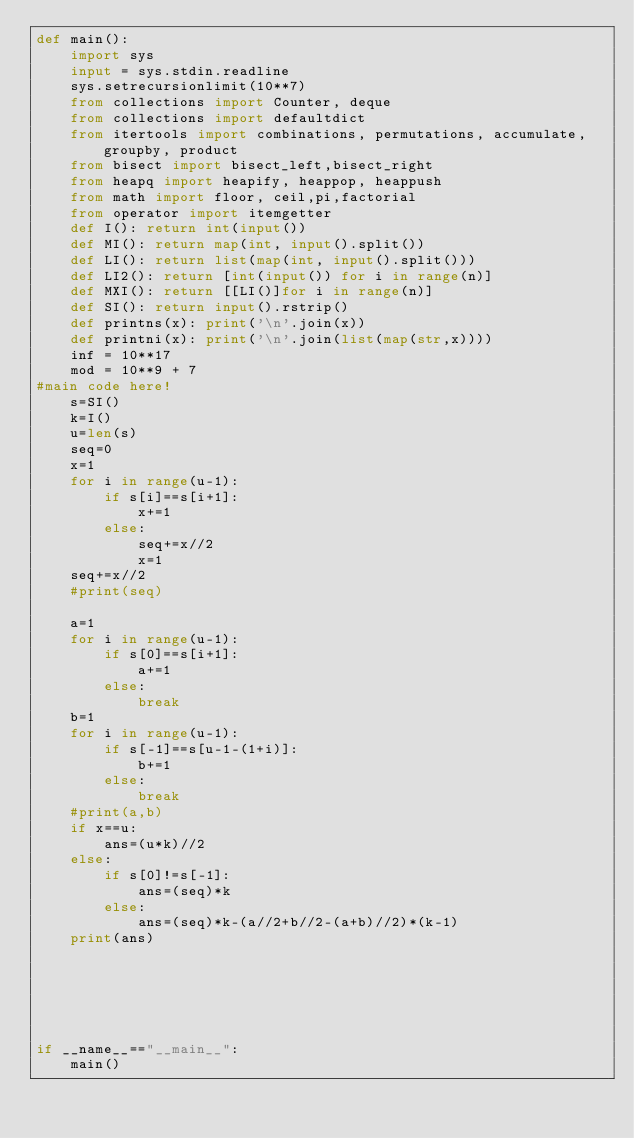Convert code to text. <code><loc_0><loc_0><loc_500><loc_500><_Python_>def main():
    import sys
    input = sys.stdin.readline
    sys.setrecursionlimit(10**7)
    from collections import Counter, deque
    from collections import defaultdict
    from itertools import combinations, permutations, accumulate, groupby, product
    from bisect import bisect_left,bisect_right
    from heapq import heapify, heappop, heappush
    from math import floor, ceil,pi,factorial
    from operator import itemgetter
    def I(): return int(input())
    def MI(): return map(int, input().split())
    def LI(): return list(map(int, input().split()))
    def LI2(): return [int(input()) for i in range(n)]
    def MXI(): return [[LI()]for i in range(n)]
    def SI(): return input().rstrip()
    def printns(x): print('\n'.join(x))
    def printni(x): print('\n'.join(list(map(str,x))))
    inf = 10**17
    mod = 10**9 + 7
#main code here!
    s=SI()
    k=I()
    u=len(s)
    seq=0
    x=1
    for i in range(u-1):
        if s[i]==s[i+1]:
            x+=1
        else:
            seq+=x//2
            x=1
    seq+=x//2
    #print(seq)
            
    a=1
    for i in range(u-1):
        if s[0]==s[i+1]:
            a+=1
        else:
            break
    b=1
    for i in range(u-1):
        if s[-1]==s[u-1-(1+i)]:
            b+=1
        else:
            break
    #print(a,b)
    if x==u:
        ans=(u*k)//2
    else:
        if s[0]!=s[-1]:
            ans=(seq)*k
        else:
            ans=(seq)*k-(a//2+b//2-(a+b)//2)*(k-1)
    print(ans)
        





if __name__=="__main__":
    main()
</code> 